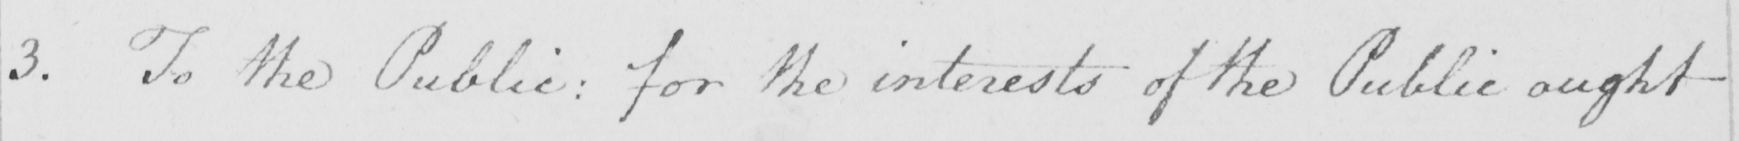Transcribe the text shown in this historical manuscript line. 3. To the Public: For the interests of the Public ought 